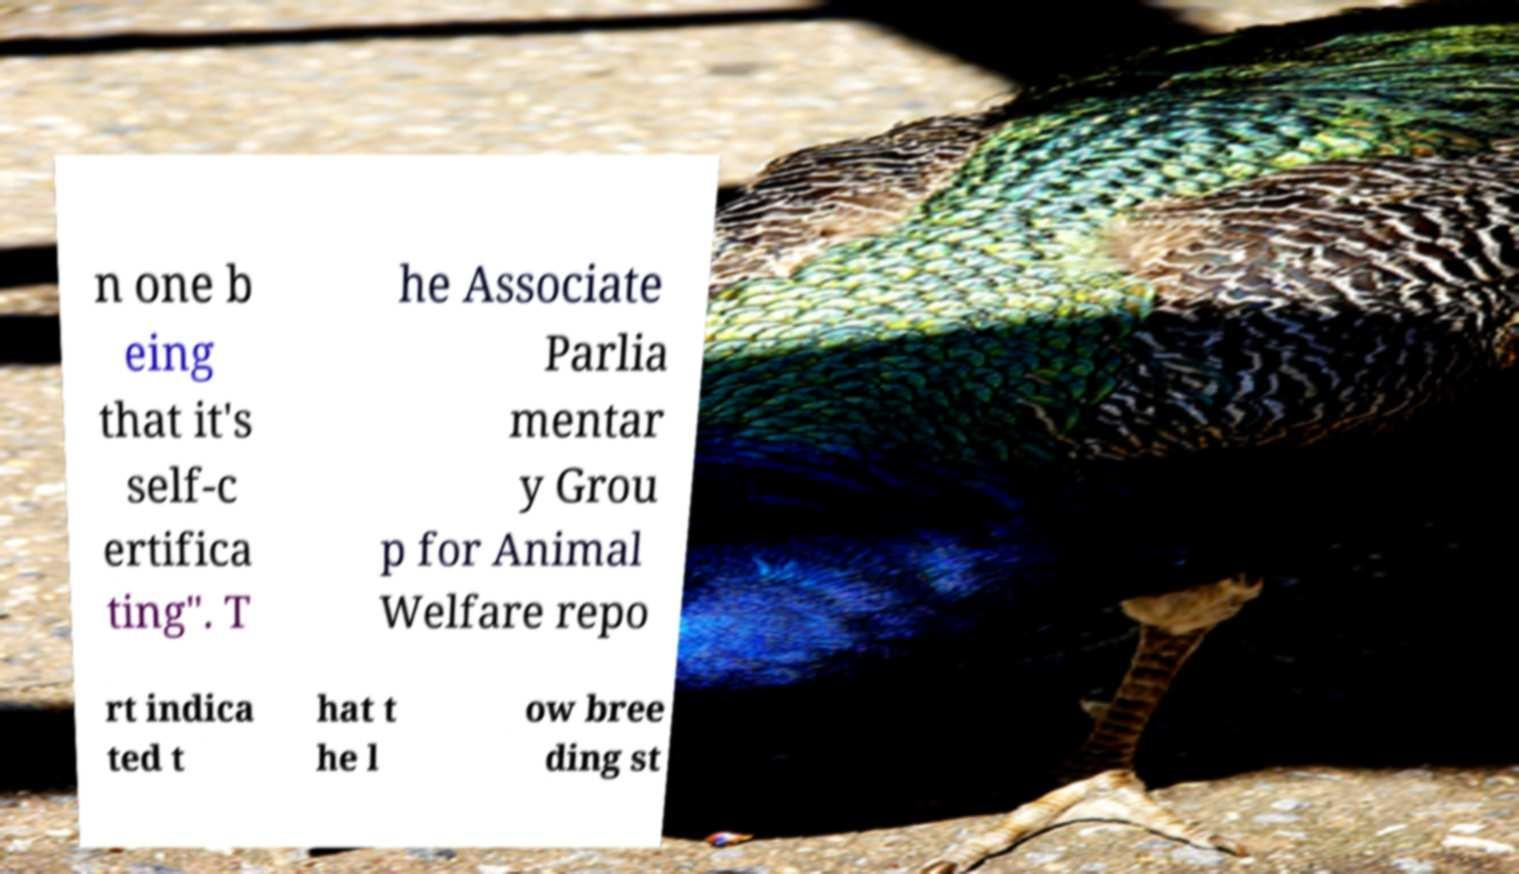Can you read and provide the text displayed in the image?This photo seems to have some interesting text. Can you extract and type it out for me? n one b eing that it's self-c ertifica ting". T he Associate Parlia mentar y Grou p for Animal Welfare repo rt indica ted t hat t he l ow bree ding st 